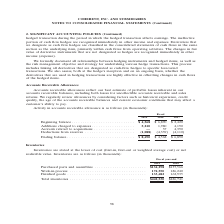According to Coherent's financial document, What do Accounts receivable allowances reflect? reflect our best estimate of probable losses inherent in our accounts receivable balances, including both losses for uncollectible accounts receivable and sales returns. The document states: "Accounts receivable allowances reflect our best estimate of probable losses inherent in our accounts receivable balances, including both losses for un..." Also, What was the Ending balance in 2019? According to the financial document, $8,690 (in thousands). The relevant text states: "Ending balance . $ 8,690 $ 4,568 $ 6,890..." Also, In which years were the accounts receivable allowances provided in the table? The document contains multiple relevant values: 2019, 2018, 2017. From the document: "Fiscal 2019 2018 2017 Fiscal 2019 2018 2017 Fiscal 2019 2018 2017..." Additionally, In which year were the Additions charged to expenses the largest? According to the financial document, 2019. The relevant text states: "Fiscal 2019 2018 2017..." Also, can you calculate: What was the change in Ending balance in 2019 from 2018? Based on the calculation: 8,690-4,568, the result is 4122 (in thousands). This is based on the information: "Ending balance . $ 8,690 $ 4,568 $ 6,890 Beginning balance . $ 4,568 $ 6,890 $ 2,420 Additions charged to expenses . 5,210 1,980 4,190 Accruals related to acquisitions..." The key data points involved are: 4,568, 8,690. Also, can you calculate: What was the percentage change in Ending balance in 2019 from 2018? To answer this question, I need to perform calculations using the financial data. The calculation is: (8,690-4,568)/4,568, which equals 90.24 (percentage). This is based on the information: "Ending balance . $ 8,690 $ 4,568 $ 6,890 Beginning balance . $ 4,568 $ 6,890 $ 2,420 Additions charged to expenses . 5,210 1,980 4,190 Accruals related to acquisitions..." The key data points involved are: 4,568, 8,690. 